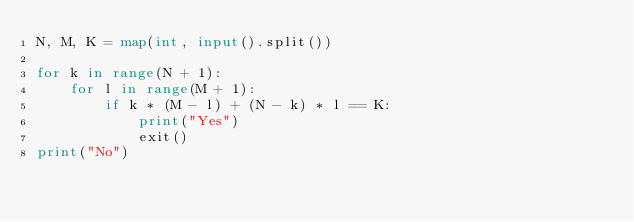Convert code to text. <code><loc_0><loc_0><loc_500><loc_500><_Python_>N, M, K = map(int, input().split())

for k in range(N + 1):
    for l in range(M + 1):
        if k * (M - l) + (N - k) * l == K:
            print("Yes")
            exit()
print("No")
</code> 